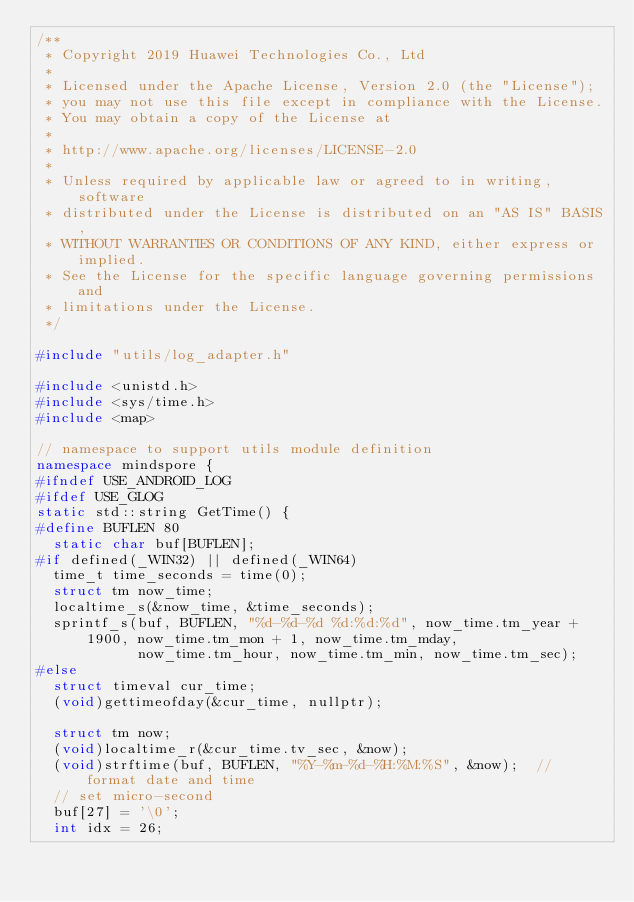<code> <loc_0><loc_0><loc_500><loc_500><_C++_>/**
 * Copyright 2019 Huawei Technologies Co., Ltd
 *
 * Licensed under the Apache License, Version 2.0 (the "License");
 * you may not use this file except in compliance with the License.
 * You may obtain a copy of the License at
 *
 * http://www.apache.org/licenses/LICENSE-2.0
 *
 * Unless required by applicable law or agreed to in writing, software
 * distributed under the License is distributed on an "AS IS" BASIS,
 * WITHOUT WARRANTIES OR CONDITIONS OF ANY KIND, either express or implied.
 * See the License for the specific language governing permissions and
 * limitations under the License.
 */

#include "utils/log_adapter.h"

#include <unistd.h>
#include <sys/time.h>
#include <map>

// namespace to support utils module definition
namespace mindspore {
#ifndef USE_ANDROID_LOG
#ifdef USE_GLOG
static std::string GetTime() {
#define BUFLEN 80
  static char buf[BUFLEN];
#if defined(_WIN32) || defined(_WIN64)
  time_t time_seconds = time(0);
  struct tm now_time;
  localtime_s(&now_time, &time_seconds);
  sprintf_s(buf, BUFLEN, "%d-%d-%d %d:%d:%d", now_time.tm_year + 1900, now_time.tm_mon + 1, now_time.tm_mday,
            now_time.tm_hour, now_time.tm_min, now_time.tm_sec);
#else
  struct timeval cur_time;
  (void)gettimeofday(&cur_time, nullptr);

  struct tm now;
  (void)localtime_r(&cur_time.tv_sec, &now);
  (void)strftime(buf, BUFLEN, "%Y-%m-%d-%H:%M:%S", &now);  // format date and time
  // set micro-second
  buf[27] = '\0';
  int idx = 26;</code> 